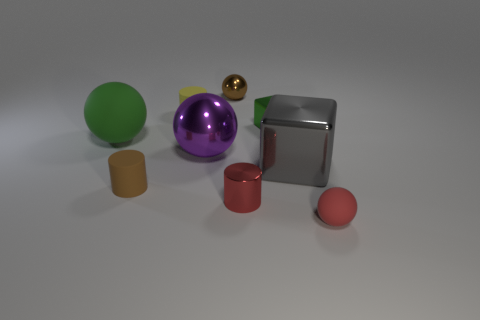Subtract 1 spheres. How many spheres are left? 3 Add 1 purple things. How many objects exist? 10 Subtract all cylinders. How many objects are left? 6 Subtract 0 blue cubes. How many objects are left? 9 Subtract all metallic objects. Subtract all big green metallic cylinders. How many objects are left? 4 Add 1 purple balls. How many purple balls are left? 2 Add 1 tiny green shiny cubes. How many tiny green shiny cubes exist? 2 